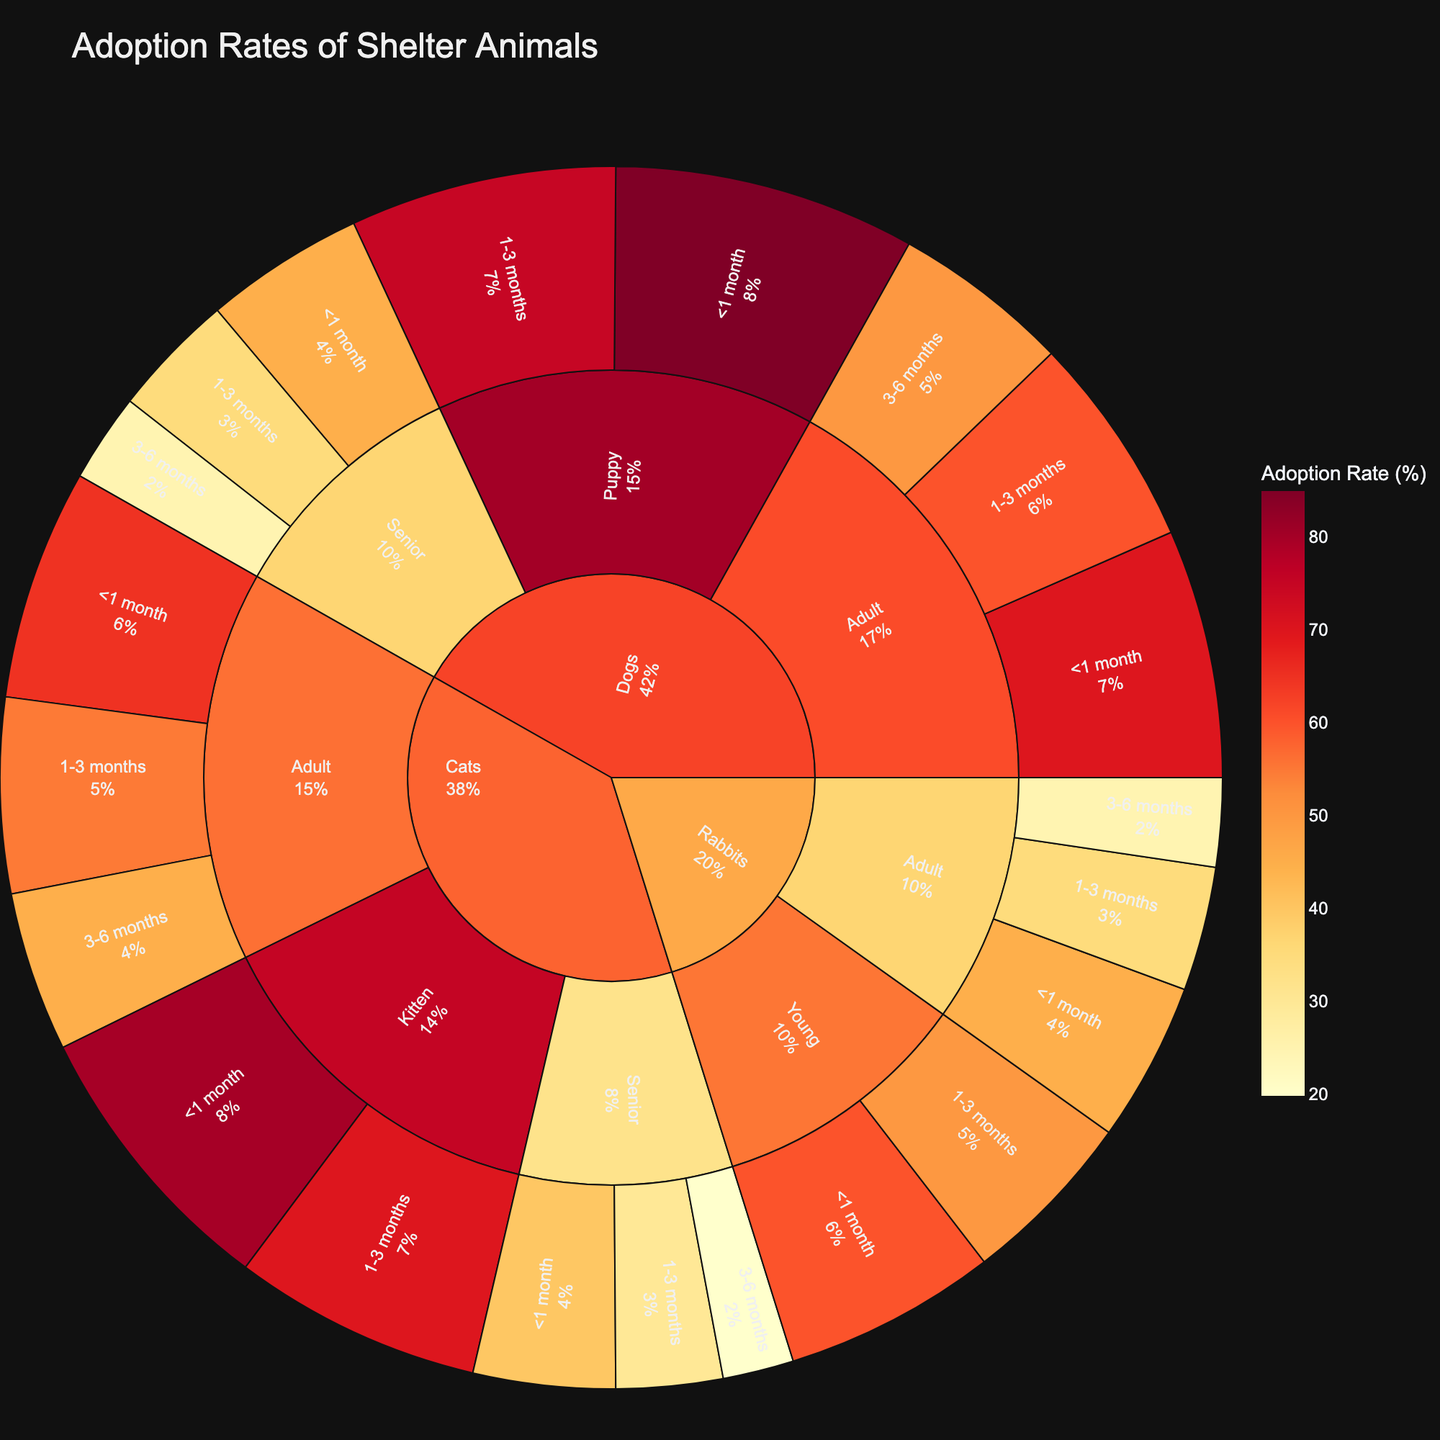What is the title of the figure? The title is prominently displayed at the top of the figure. It summarizes the overall theme of the plot regarding the metric being visualized.
Answer: Adoption Rates of Shelter Animals Which species has the highest adoption rate overall? To determine this, find the outermost segment with the highest percentage value. Compare the highest values across species segments.
Answer: Dogs What are the adoption rates for adult rabbits based on length of stay? Navigate to the "Rabbits" segment, then to the "Adult" sub-segment. The adoption rates will be segmented by the different "length of stay" categories visible.
Answer: <1 month: 45%, 1-3 months: 35%, 3-6 months: 25% Compare the adoption rates of senior cats and senior dogs for the '<1 month' length of stay. Which has a higher adoption rate? Locate the "Senior" sub-segments of both "Dogs" and "Cats" under the '<1 month' length of stay. Compare the adoption rates indicated.
Answer: Dogs: 45%, Cats: 40% – Dogs have a higher rate What is the difference in adoption rates between adult dogs that stayed for '3-6 months' and '1-3 months'? Find the adoption rates for adult dogs under '3-6 months' and '1-3 months.' Subtract the '3-6 months' rate from the '1-3 months' rate.
Answer: 60% - 50% = 10% Which age category of animals has the lowest adoption rate for a '1-3 months' length of stay? Compare the adoption rates for all age categories within the '1-3 months' length of stay segments for each species. Identify the lowest rate.
Answer: Senior Cats: 30% How do the adoption rates of kittens compare to puppies within the '<1 month' length of stay? Navigate to the '<1 month' segments for both "Cats" (Kittens) and "Dogs" (Puppies). Compare the adoption rates displayed.
Answer: Kittens: 80%, Puppies: 85% – Puppies have a higher rate What is the total adoption rate for young rabbits staying less than 3 months? Sum the adoption rates for young rabbits staying '<1 month' and '1-3 months.'
Answer: 60% + 50% = 110% 